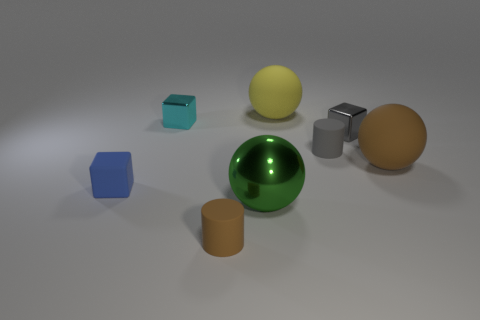Add 2 cyan metallic things. How many objects exist? 10 Subtract all blocks. How many objects are left? 5 Add 2 big green metallic cylinders. How many big green metallic cylinders exist? 2 Subtract 0 blue cylinders. How many objects are left? 8 Subtract all large red metal cylinders. Subtract all tiny blue rubber objects. How many objects are left? 7 Add 7 tiny matte cubes. How many tiny matte cubes are left? 8 